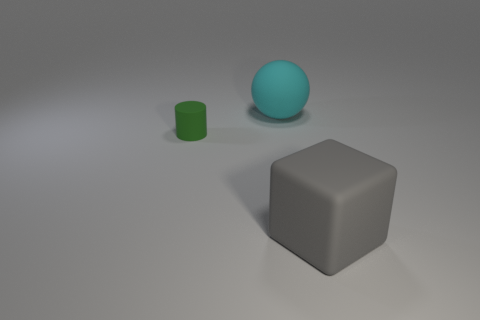What time of day does the lighting in the scene suggest? The lighting in the scene does not strongly suggest any particular time of day, as it's a controlled environment with an artificial, ambient light source that provides a soft illumination to the objects without a clear indication of natural light from the sun. Could these objects be used in any typical setting, or do they seem purely decorative? These objects, in their current state, appear to be more illustrative or decorative. Their simplistic design and lack of additional features or context do not indicate a specific practical use. They could, however, serve as teaching tools for educational purposes to demonstrate the concept of shapes and volume in a visual manner. 